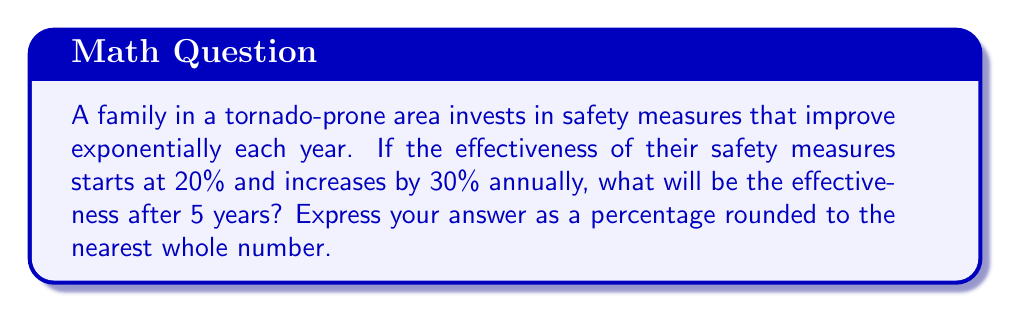Can you answer this question? Let's approach this step-by-step:

1) The initial effectiveness is 20% or 0.20.
2) Each year, the effectiveness increases by 30% or 1.30 times.
3) We need to calculate this over 5 years.

We can express this mathematically as:

$$ \text{Effectiveness} = 0.20 \times (1.30)^5 $$

Let's solve:

$$ \begin{align}
\text{Effectiveness} &= 0.20 \times (1.30)^5 \\
&= 0.20 \times 3.71293 \\
&= 0.742586
\end{align} $$

Converting to a percentage:

$$ 0.742586 \times 100\% = 74.2586\% $$

Rounding to the nearest whole number:

$$ 74.2586\% \approx 74\% $$
Answer: 74% 